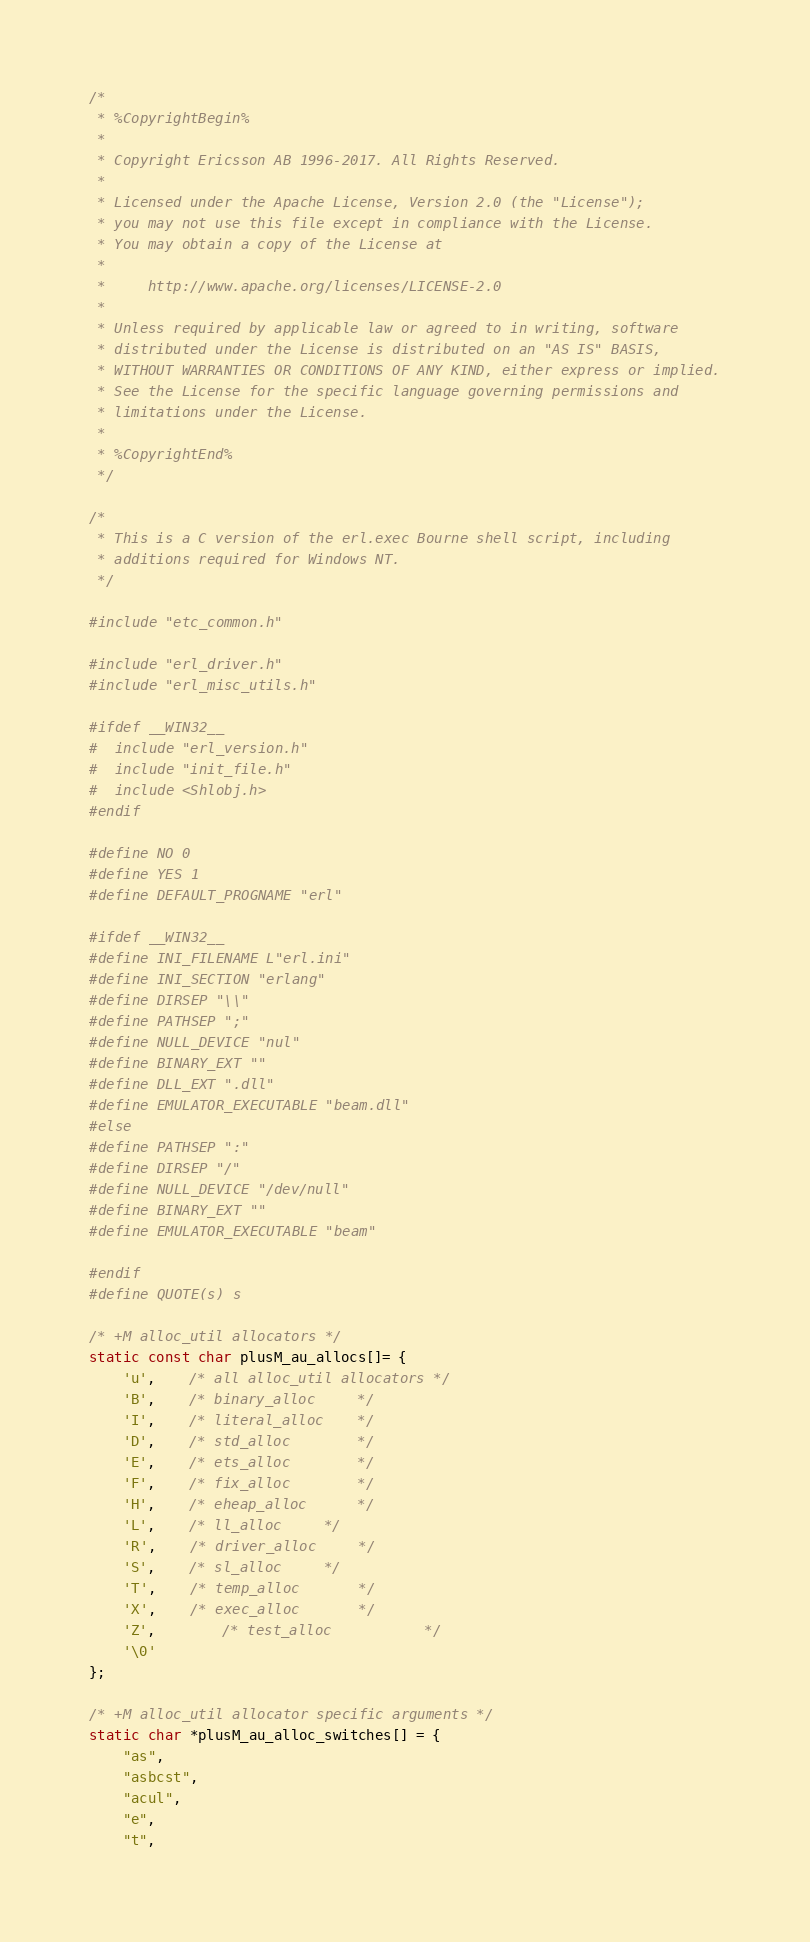Convert code to text. <code><loc_0><loc_0><loc_500><loc_500><_C_>/*
 * %CopyrightBegin%
 *
 * Copyright Ericsson AB 1996-2017. All Rights Reserved.
 *
 * Licensed under the Apache License, Version 2.0 (the "License");
 * you may not use this file except in compliance with the License.
 * You may obtain a copy of the License at
 *
 *     http://www.apache.org/licenses/LICENSE-2.0
 *
 * Unless required by applicable law or agreed to in writing, software
 * distributed under the License is distributed on an "AS IS" BASIS,
 * WITHOUT WARRANTIES OR CONDITIONS OF ANY KIND, either express or implied.
 * See the License for the specific language governing permissions and
 * limitations under the License.
 *
 * %CopyrightEnd%
 */

/*
 * This is a C version of the erl.exec Bourne shell script, including
 * additions required for Windows NT.
 */

#include "etc_common.h"

#include "erl_driver.h"
#include "erl_misc_utils.h"

#ifdef __WIN32__
#  include "erl_version.h"
#  include "init_file.h"
#  include <Shlobj.h>
#endif

#define NO 0
#define YES 1
#define DEFAULT_PROGNAME "erl"

#ifdef __WIN32__
#define INI_FILENAME L"erl.ini"
#define INI_SECTION "erlang"
#define DIRSEP "\\"
#define PATHSEP ";"
#define NULL_DEVICE "nul"
#define BINARY_EXT ""
#define DLL_EXT ".dll"
#define EMULATOR_EXECUTABLE "beam.dll"
#else
#define PATHSEP ":"
#define DIRSEP "/"
#define NULL_DEVICE "/dev/null"
#define BINARY_EXT ""
#define EMULATOR_EXECUTABLE "beam"

#endif
#define QUOTE(s) s

/* +M alloc_util allocators */
static const char plusM_au_allocs[]= {
    'u',	/* all alloc_util allocators */
    'B',	/* binary_alloc		*/
    'I',	/* literal_alloc	*/
    'D',	/* std_alloc		*/
    'E',	/* ets_alloc		*/
    'F',	/* fix_alloc		*/
    'H',	/* eheap_alloc		*/
    'L',	/* ll_alloc		*/
    'R',	/* driver_alloc		*/
    'S',	/* sl_alloc		*/
    'T',	/* temp_alloc		*/
    'X',	/* exec_alloc		*/
    'Z',        /* test_alloc           */
    '\0'
};

/* +M alloc_util allocator specific arguments */
static char *plusM_au_alloc_switches[] = {
    "as",
    "asbcst",
    "acul",
    "e",
    "t",</code> 